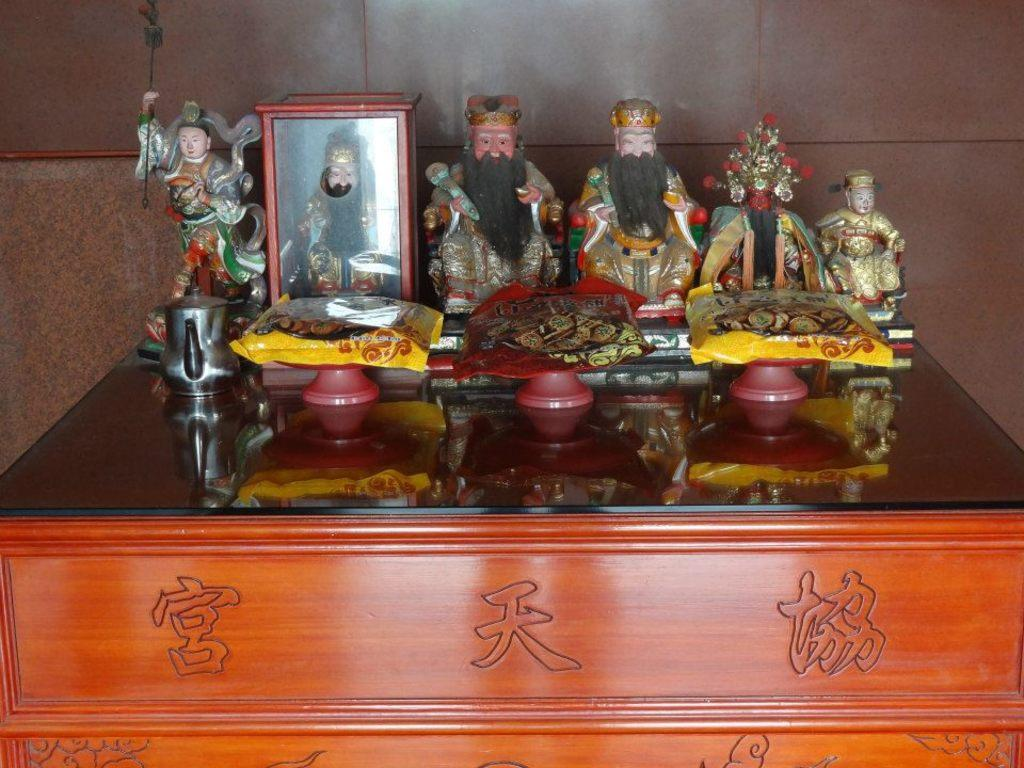What is the main piece of furniture in the image? There is a table in the image. What is placed on the table? There is a statue of a person on the table, as well as multiple statues of persons. What else can be seen on the table? There are bowls and packets of boxes on the table. How many clover leaves can be seen on the table in the image? There are no clover leaves present in the image. What type of mouth is visible on the statue in the image? There is no mouth visible on the statue in the image, as it is a statue and not a living being. 